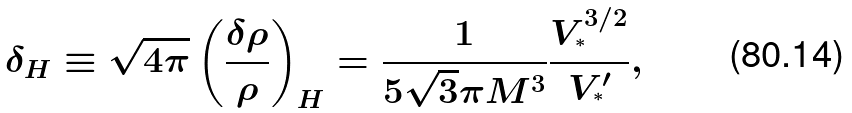Convert formula to latex. <formula><loc_0><loc_0><loc_500><loc_500>\delta _ { H } \equiv \sqrt { 4 \pi } \left ( \frac { \delta \rho } { \rho } \right ) _ { H } = \frac { 1 } { 5 \sqrt { 3 } \pi M ^ { 3 } } \frac { V _ { ^ { * } } ^ { 3 / 2 } } { V _ { ^ { * } } ^ { \prime } } ,</formula> 